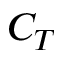Convert formula to latex. <formula><loc_0><loc_0><loc_500><loc_500>C _ { T }</formula> 